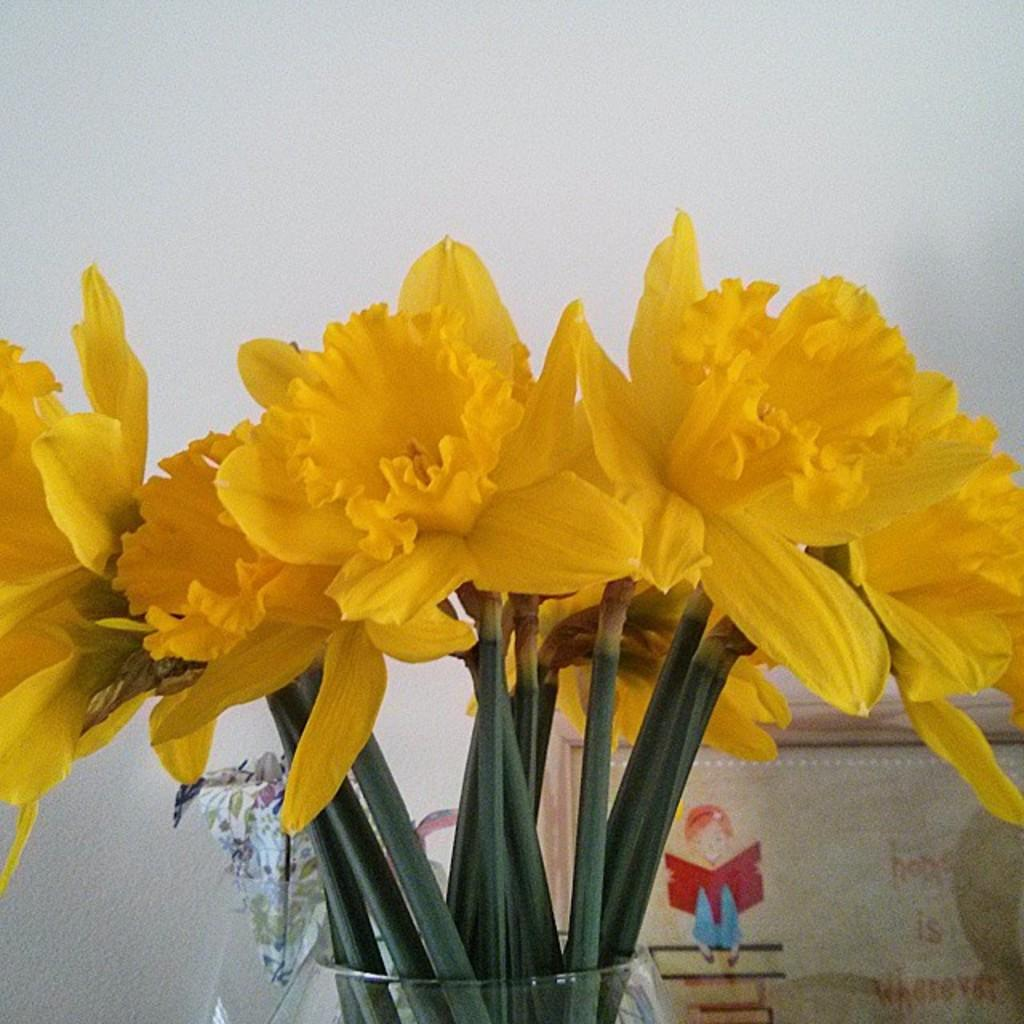What type of plants can be seen in the image? There are flowers in the image. How many vases are present in the image? There are two vases in the image. Can you describe the object on the right side of the image? Unfortunately, the facts provided do not give any information about the object on the right side of the image. What type of crime is being committed in the image? There is no indication of any crime being committed in the image; it features flowers and vases. What does the mouth of the flower look like in the image? There is no mention of a flower with a mouth in the image; flowers do not have mouths. 